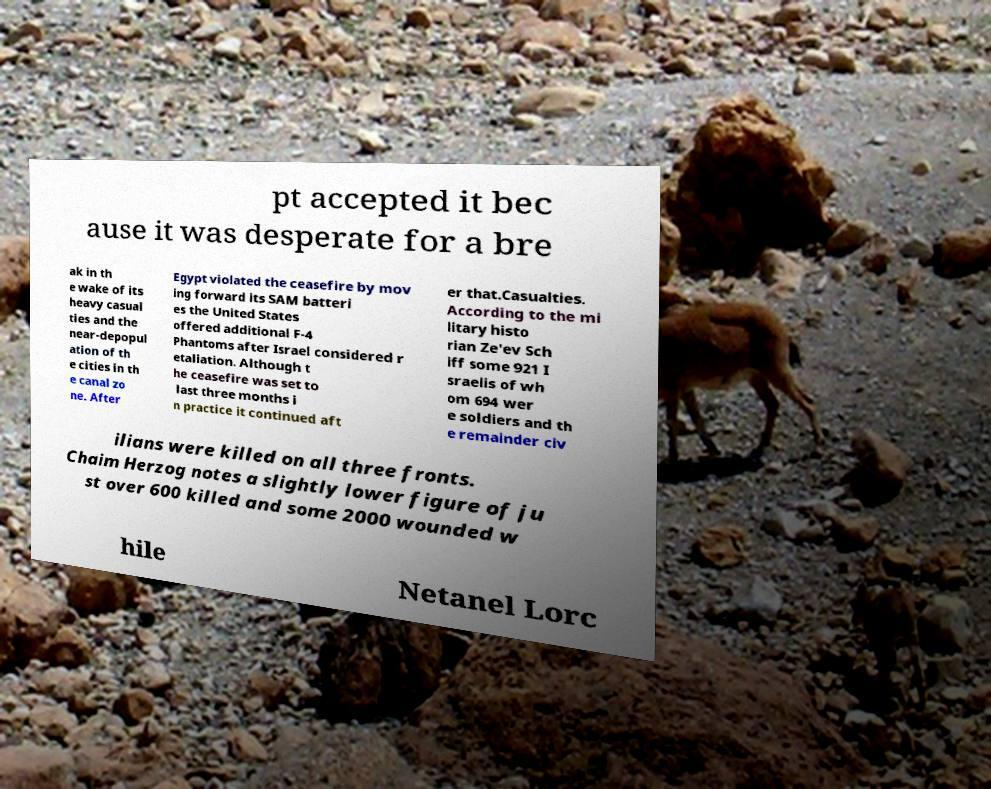Could you assist in decoding the text presented in this image and type it out clearly? pt accepted it bec ause it was desperate for a bre ak in th e wake of its heavy casual ties and the near-depopul ation of th e cities in th e canal zo ne. After Egypt violated the ceasefire by mov ing forward its SAM batteri es the United States offered additional F-4 Phantoms after Israel considered r etaliation. Although t he ceasefire was set to last three months i n practice it continued aft er that.Casualties. According to the mi litary histo rian Ze'ev Sch iff some 921 I sraelis of wh om 694 wer e soldiers and th e remainder civ ilians were killed on all three fronts. Chaim Herzog notes a slightly lower figure of ju st over 600 killed and some 2000 wounded w hile Netanel Lorc 